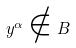Convert formula to latex. <formula><loc_0><loc_0><loc_500><loc_500>y ^ { \alpha } \notin B</formula> 